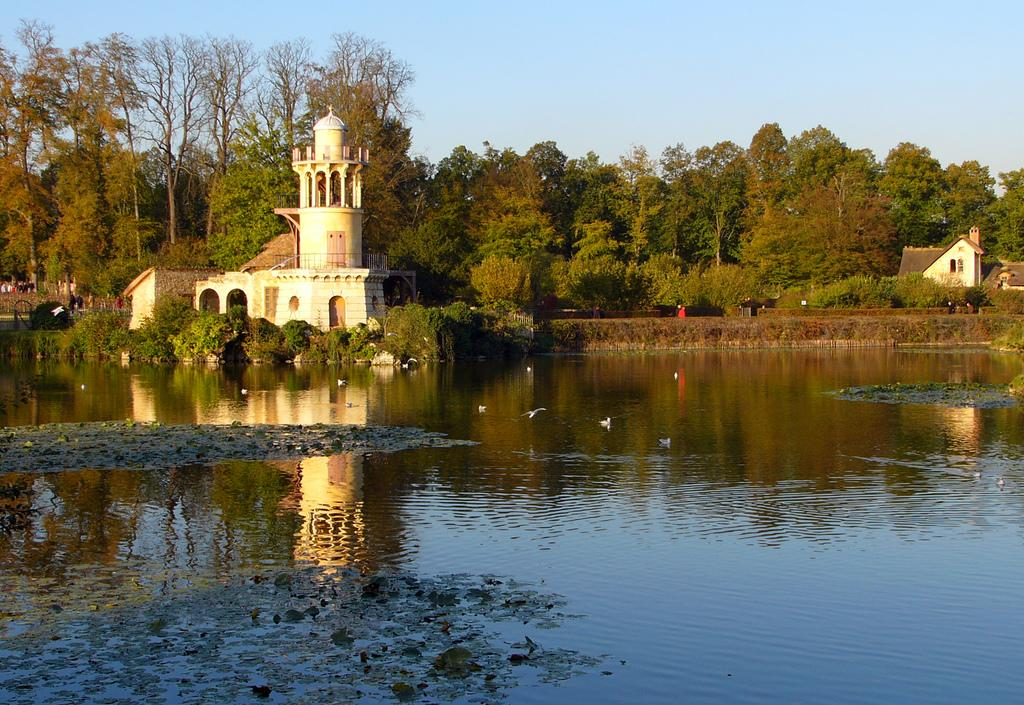What is the main element present in the image? There is water in the image. What type of animals can be seen in the image? Birds can be seen in the image. What can be seen in the background of the image? There are trees, plants, and houses in the background of the image. What is the color of the sky in the image? The sky is blue in color. What type of account is being discussed in the image? There is no account being discussed in the image; it features water, birds, and a blue sky. What holiday is being celebrated in the image? There is no holiday being celebrated in the image; it simply shows water, birds, and a blue sky. 